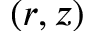<formula> <loc_0><loc_0><loc_500><loc_500>( r , z )</formula> 